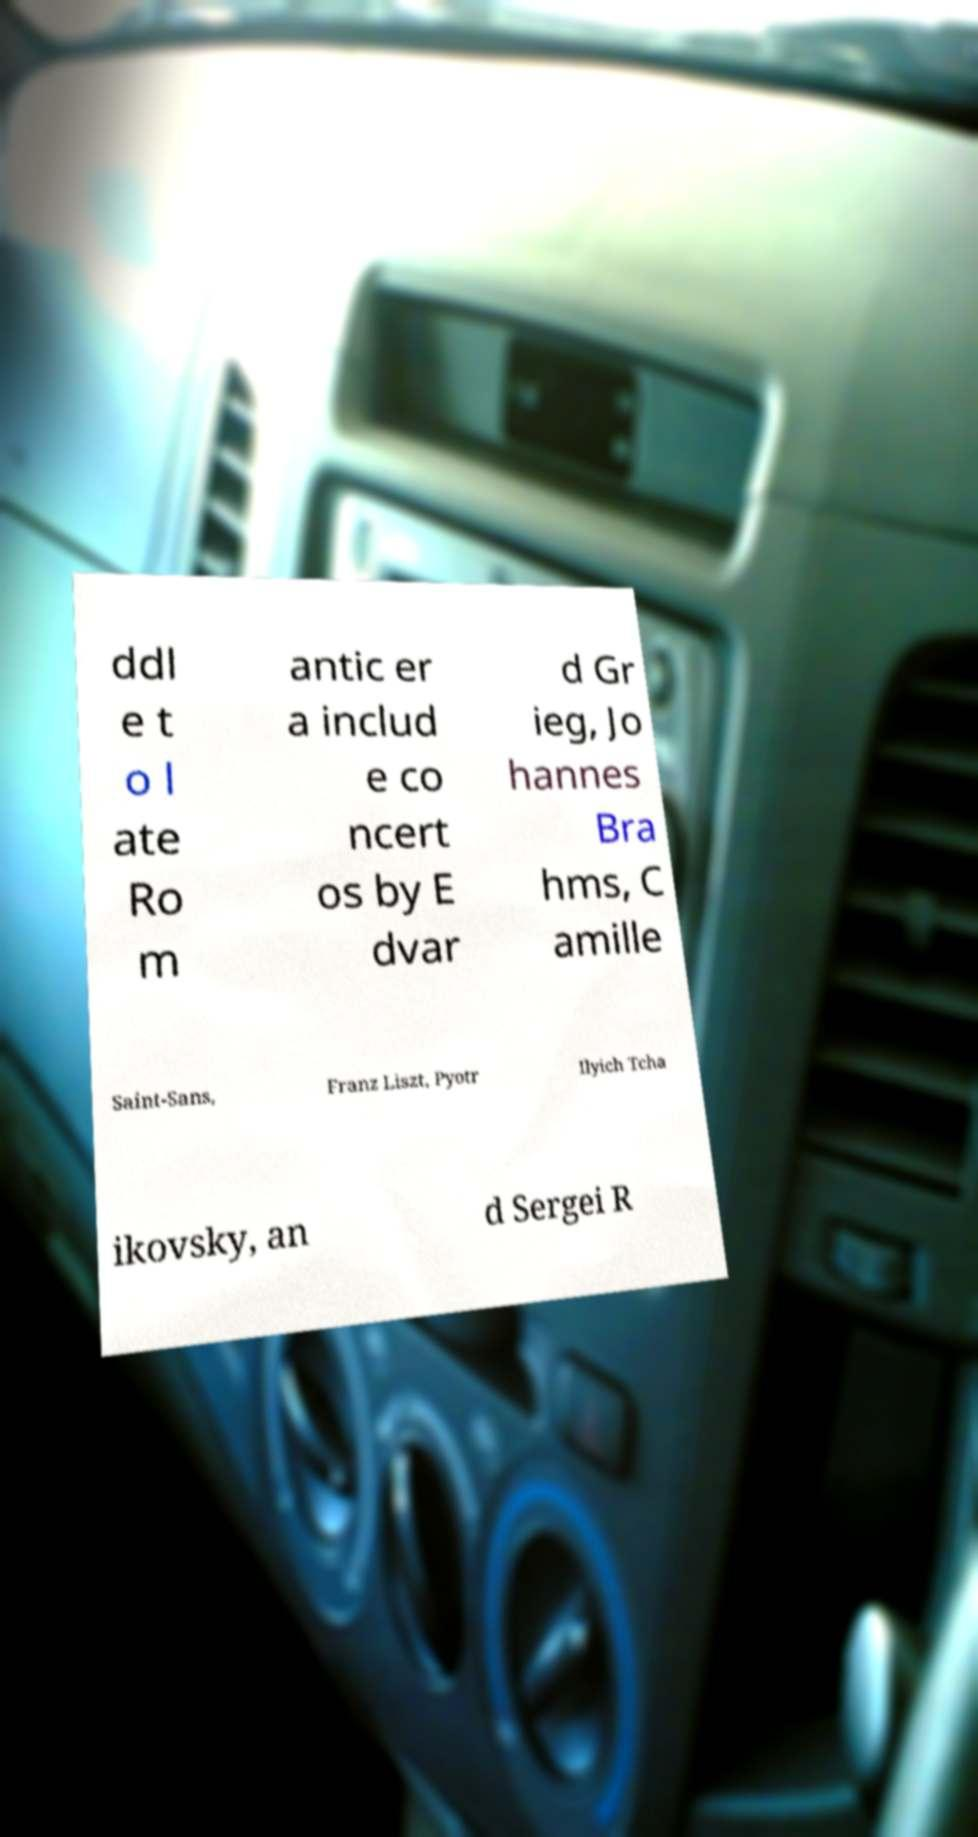For documentation purposes, I need the text within this image transcribed. Could you provide that? ddl e t o l ate Ro m antic er a includ e co ncert os by E dvar d Gr ieg, Jo hannes Bra hms, C amille Saint-Sans, Franz Liszt, Pyotr Ilyich Tcha ikovsky, an d Sergei R 